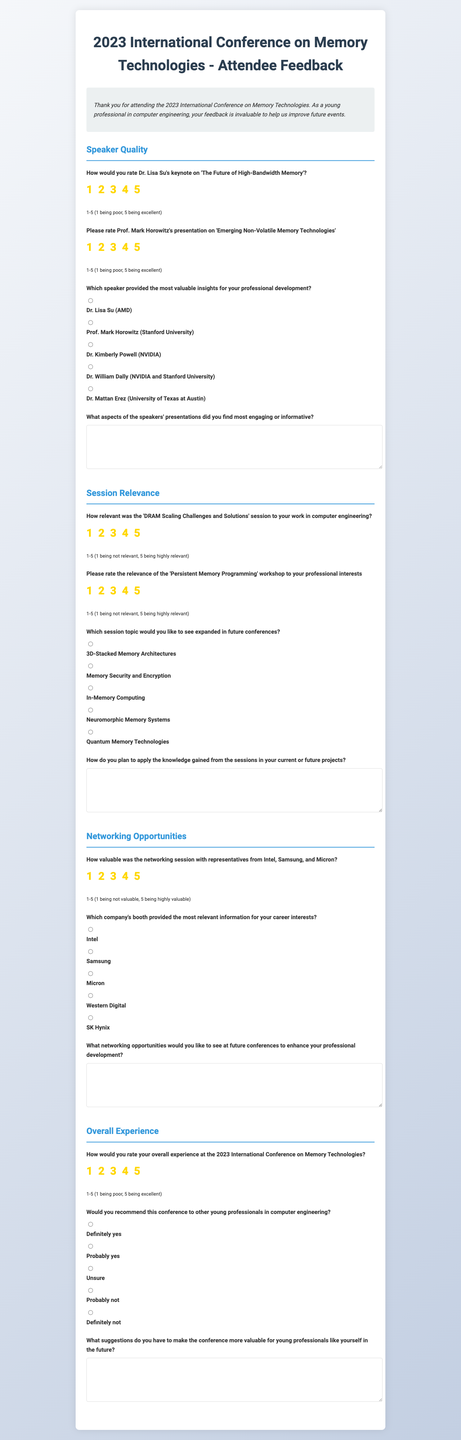How would you rate Dr. Lisa Su's keynote? The document asks attendees to rate Dr. Lisa Su's keynote presentation on a scale from 1 to 5.
Answer: 1-5 What is the main topic of Prof. Mark Horowitz's presentation? The document indicates that Prof. Mark Horowitz presented on 'Emerging Non-Volatile Memory Technologies'.
Answer: Emerging Non-Volatile Memory Technologies Which speaker is noted for providing valuable insights for professional development? The document lists multiple speakers and inquires which one attendees found most valuable for their career.
Answer: Dr. Lisa Su (AMD) What session topic is rated for relevance to work in computer engineering? The survey includes a specific session titled 'DRAM Scaling Challenges and Solutions' related to the relevance of the content.
Answer: DRAM Scaling Challenges and Solutions How relevant is the 'Persistent Memory Programming' workshop rated to interests? Attendees are asked to rate the relevance of the 'Persistent Memory Programming' topic on a 1-5 scale in the document.
Answer: 1-5 Which session topic is suggested for expansion in future conferences? The document offers multiple options for session topics attendees would like to see expanded in future events.
Answer: 3D-Stacked Memory Architectures What overall rating scale is used for the conference experience? The document specifies that attendees rate their overall experience on a scale from 1 to 5.
Answer: 1-5 Would you recommend the conference to others? Attendees are questioned about recommending the conference, offering several options for answer.
Answer: Definitely yes What networking opportunity is evaluated for value? The survey includes a rating question regarding the networking session with representatives from multiple companies.
Answer: 1-5 